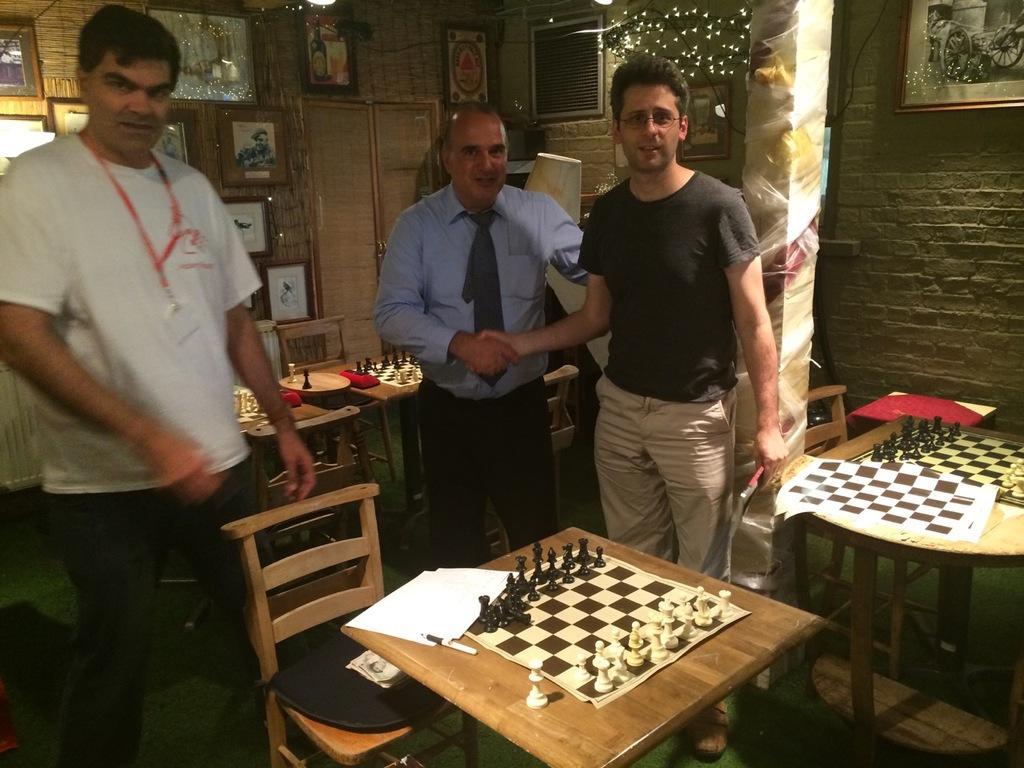Could you give a brief overview of what you see in this image? In the image we can see three people standing. There are many chairs and table, on the table we can see a chess board, these are the chess coins. This is the pillar and a photo frame stick on the wall. There are lights. 